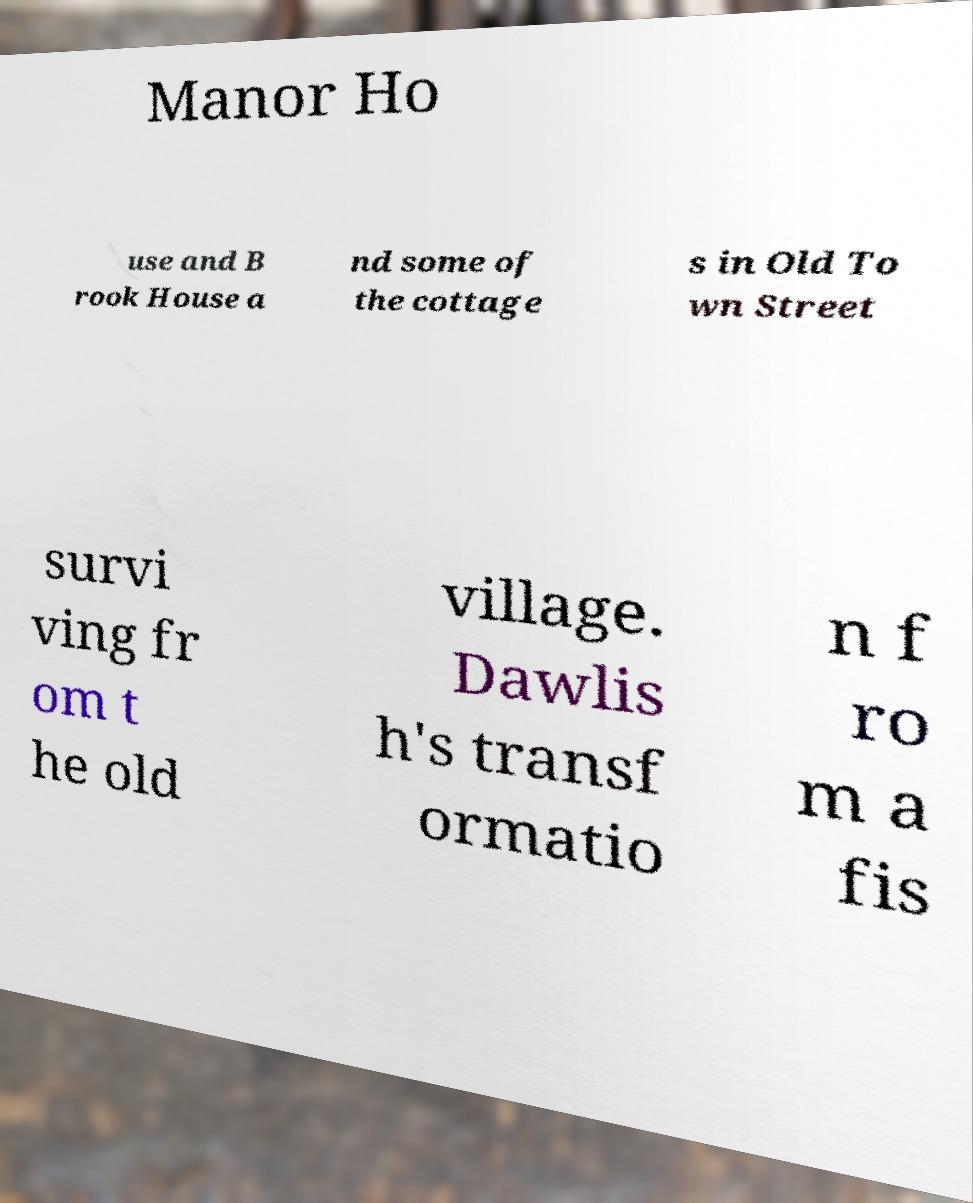There's text embedded in this image that I need extracted. Can you transcribe it verbatim? Manor Ho use and B rook House a nd some of the cottage s in Old To wn Street survi ving fr om t he old village. Dawlis h's transf ormatio n f ro m a fis 